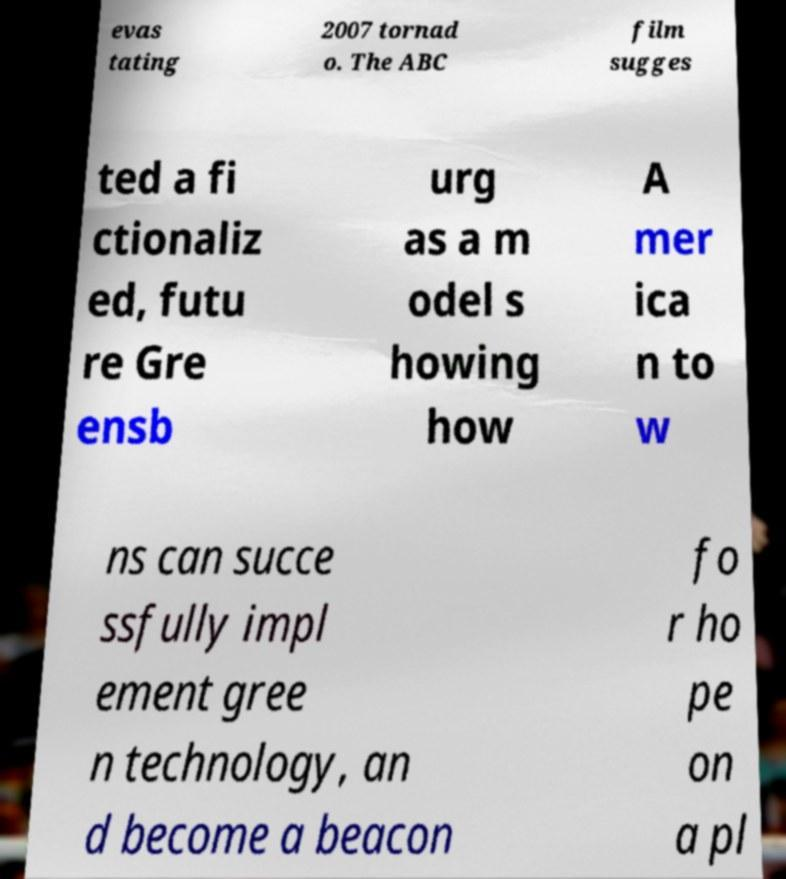Please read and relay the text visible in this image. What does it say? evas tating 2007 tornad o. The ABC film sugges ted a fi ctionaliz ed, futu re Gre ensb urg as a m odel s howing how A mer ica n to w ns can succe ssfully impl ement gree n technology, an d become a beacon fo r ho pe on a pl 